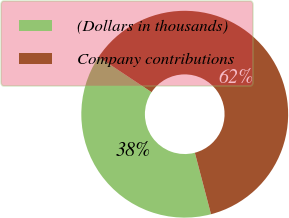Convert chart to OTSL. <chart><loc_0><loc_0><loc_500><loc_500><pie_chart><fcel>(Dollars in thousands)<fcel>Company contributions<nl><fcel>38.42%<fcel>61.58%<nl></chart> 